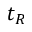<formula> <loc_0><loc_0><loc_500><loc_500>t _ { R }</formula> 